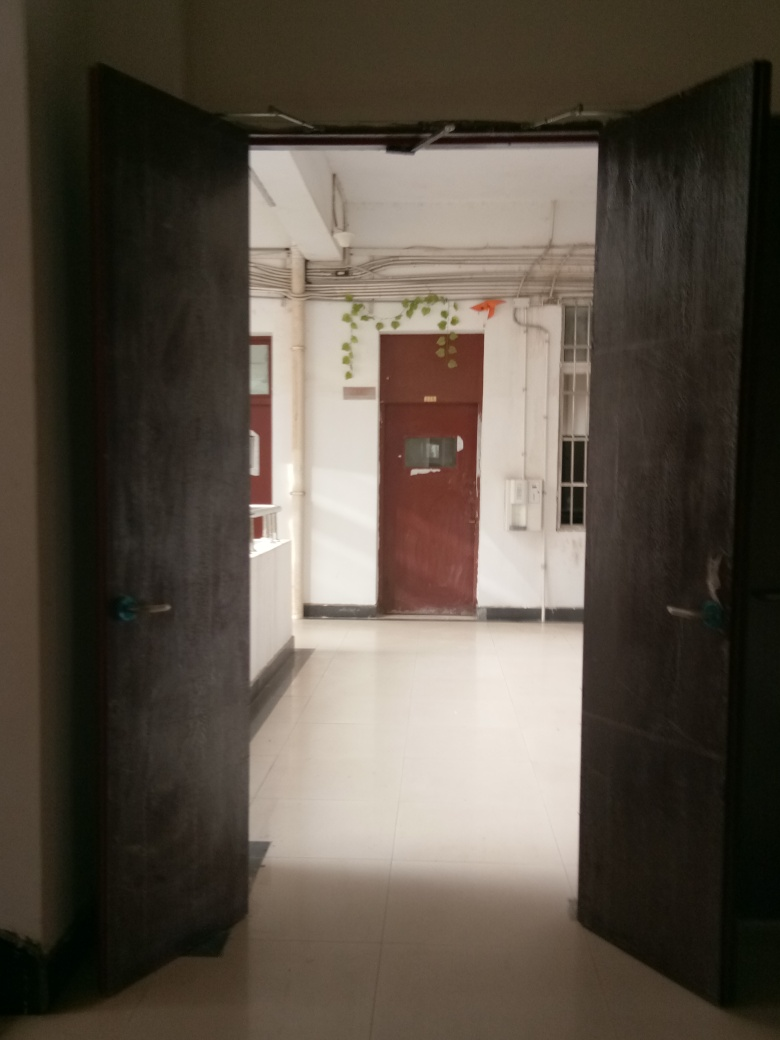Can you describe the lighting and ambiance of the space beyond the door? The space beyond the door is brightly illuminated by natural daylight, likely from windows not visible in the image. The ambiance of the corridor is stark and utilitarian, with a clean, uncluttered appearance, white walls, and minimal decor. 